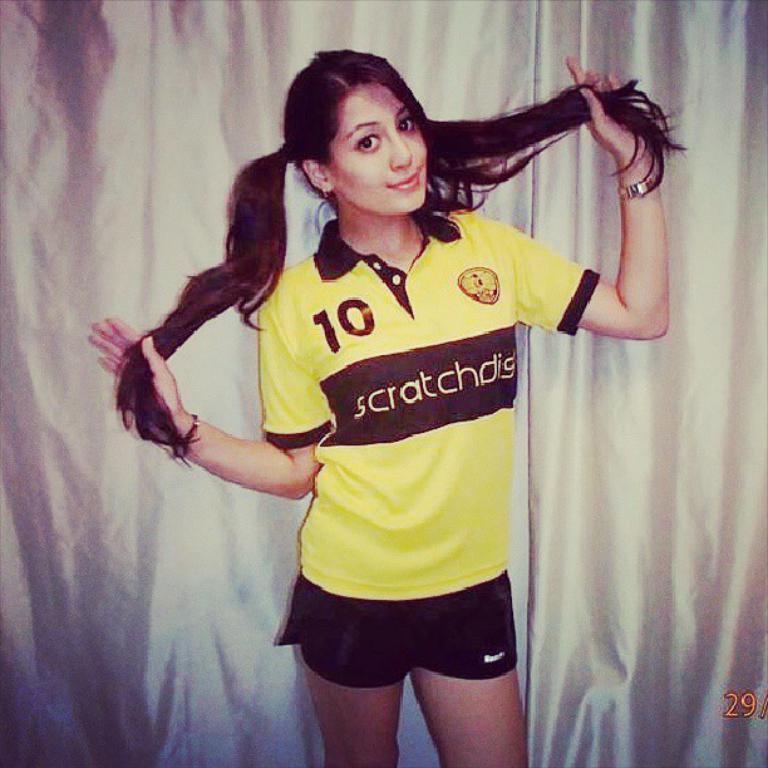What does her shirt say in the middle?
Offer a very short reply. Scratchdis. 